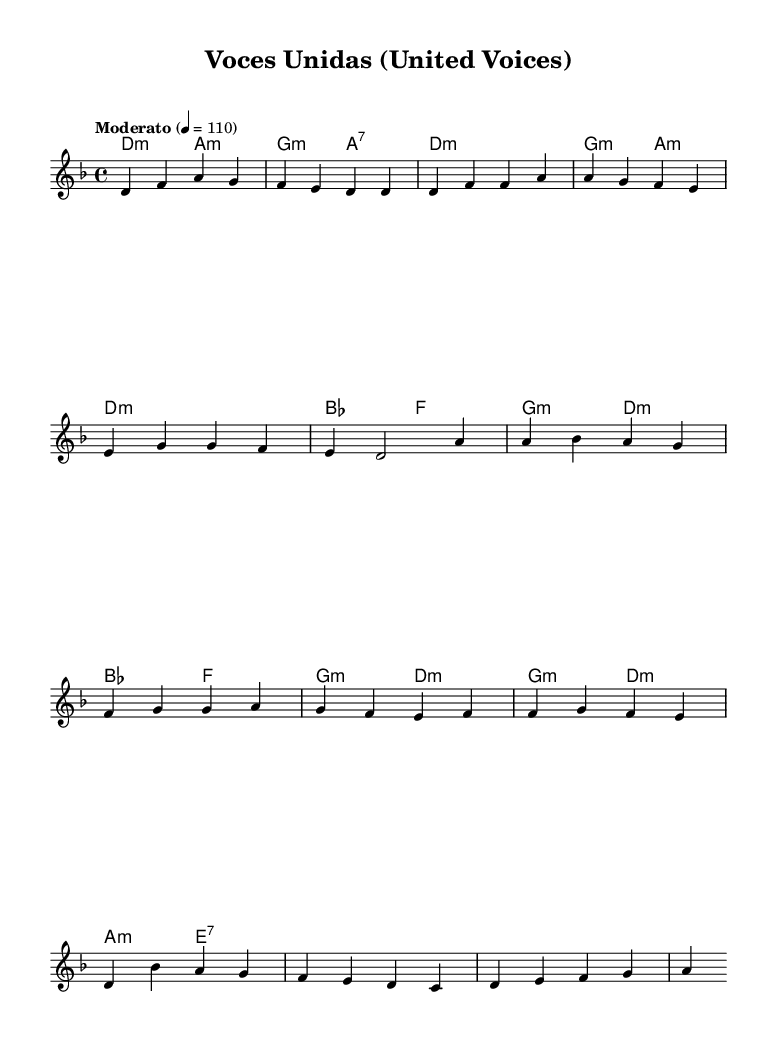What is the key signature of this music? The music is in D minor, which features one flat (B flat) in its key signature. This can be identified from the global section at the top of the code, where it specifies the key as "d \minor".
Answer: D minor What is the time signature of this piece? The time signature is 4/4, as indicated in the global section of the code. It specifies the number of beats per measure (4) and the note value that gets one beat (quarter note).
Answer: 4/4 What is the tempo marking for this piece? The tempo marking is "Moderato" with a metronome marking of 110 beats per minute. This is seen in the global section of the code where tempo is defined.
Answer: Moderato How many measures are in the chorus section? The chorus consists of 4 measures, which can be counted in the melody portion from the provided music data. Each line has a specified number of beats, and by summing them, we confirm there are 4 measures.
Answer: 4 What chord follows the bridge section? The bridge section ends with an E7 chord, as indicated in the harmonies section. We can determine this by looking at the sequence of chords in the bridge to find the last chord listed.
Answer: E7 What is the first note of the piece? The first note of the piece is D, as shown in the melody section where it begins with a D4 note. This is the starting point of the melody and can be directly seen in the notation provided.
Answer: D What is the overall theme suggested by the title "Voces Unidas"? The title "Voces Unidas" translates to "United Voices," suggesting a theme of collective unity and protest. This aligns with the focus on contemporary Latin protest songs addressing global political issues, reflecting a spirit of solidarity against adversity.
Answer: United Voices 